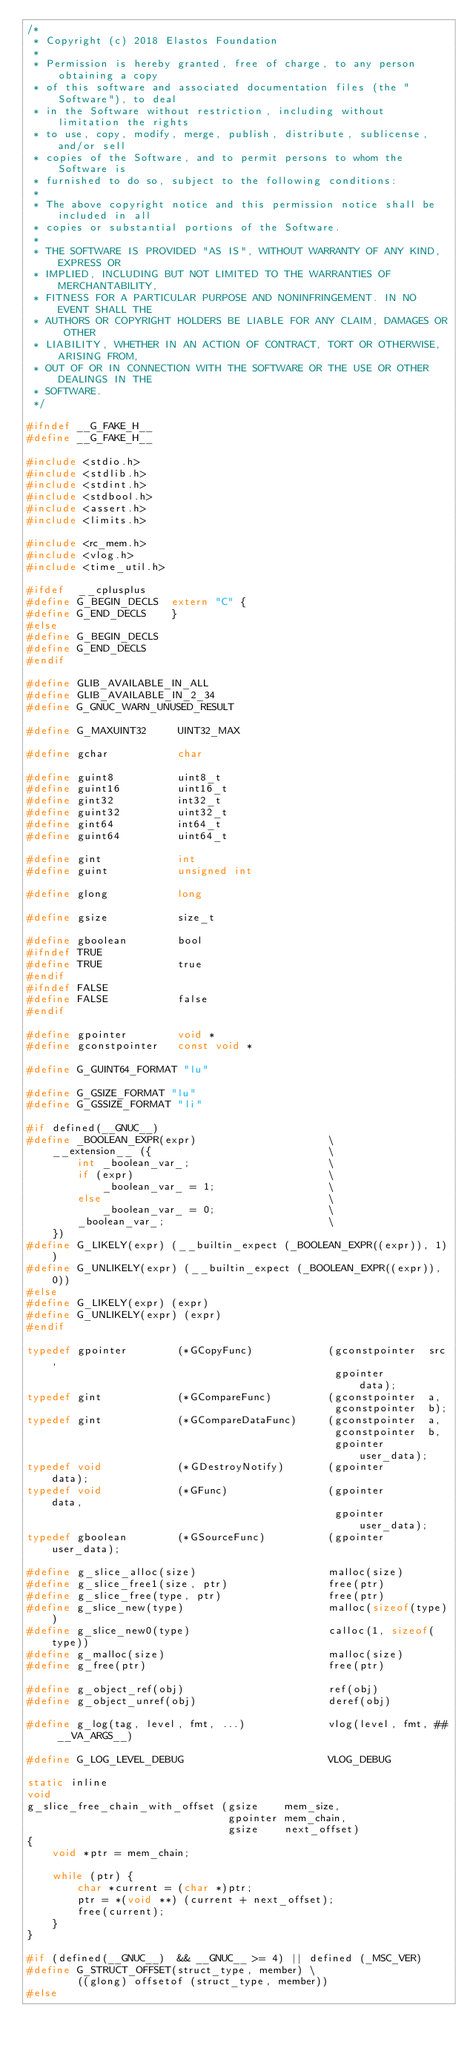<code> <loc_0><loc_0><loc_500><loc_500><_C_>/*
 * Copyright (c) 2018 Elastos Foundation
 *
 * Permission is hereby granted, free of charge, to any person obtaining a copy
 * of this software and associated documentation files (the "Software"), to deal
 * in the Software without restriction, including without limitation the rights
 * to use, copy, modify, merge, publish, distribute, sublicense, and/or sell
 * copies of the Software, and to permit persons to whom the Software is
 * furnished to do so, subject to the following conditions:
 *
 * The above copyright notice and this permission notice shall be included in all
 * copies or substantial portions of the Software.
 *
 * THE SOFTWARE IS PROVIDED "AS IS", WITHOUT WARRANTY OF ANY KIND, EXPRESS OR
 * IMPLIED, INCLUDING BUT NOT LIMITED TO THE WARRANTIES OF MERCHANTABILITY,
 * FITNESS FOR A PARTICULAR PURPOSE AND NONINFRINGEMENT. IN NO EVENT SHALL THE
 * AUTHORS OR COPYRIGHT HOLDERS BE LIABLE FOR ANY CLAIM, DAMAGES OR OTHER
 * LIABILITY, WHETHER IN AN ACTION OF CONTRACT, TORT OR OTHERWISE, ARISING FROM,
 * OUT OF OR IN CONNECTION WITH THE SOFTWARE OR THE USE OR OTHER DEALINGS IN THE
 * SOFTWARE.
 */

#ifndef __G_FAKE_H__
#define __G_FAKE_H__

#include <stdio.h>
#include <stdlib.h>
#include <stdint.h>
#include <stdbool.h>
#include <assert.h>
#include <limits.h>

#include <rc_mem.h>
#include <vlog.h>
#include <time_util.h>

#ifdef  __cplusplus
#define G_BEGIN_DECLS  extern "C" {
#define G_END_DECLS    }
#else
#define G_BEGIN_DECLS
#define G_END_DECLS
#endif

#define GLIB_AVAILABLE_IN_ALL
#define GLIB_AVAILABLE_IN_2_34
#define G_GNUC_WARN_UNUSED_RESULT

#define G_MAXUINT32     UINT32_MAX

#define gchar           char

#define guint8          uint8_t
#define guint16         uint16_t
#define gint32          int32_t
#define guint32         uint32_t
#define gint64          int64_t
#define guint64         uint64_t

#define gint            int
#define guint           unsigned int

#define glong           long

#define gsize           size_t

#define gboolean        bool
#ifndef TRUE
#define TRUE            true
#endif
#ifndef FALSE
#define FALSE           false
#endif

#define gpointer        void *
#define gconstpointer   const void *

#define G_GUINT64_FORMAT "lu"

#define G_GSIZE_FORMAT "lu"
#define G_GSSIZE_FORMAT "li"

#if defined(__GNUC__)
#define _BOOLEAN_EXPR(expr)                     \
    __extension__ ({                            \
        int _boolean_var_;                      \
        if (expr)                               \
            _boolean_var_ = 1;                  \
        else                                    \
            _boolean_var_ = 0;                  \
        _boolean_var_;                          \
    })
#define G_LIKELY(expr) (__builtin_expect (_BOOLEAN_EXPR((expr)), 1))
#define G_UNLIKELY(expr) (__builtin_expect (_BOOLEAN_EXPR((expr)), 0))
#else
#define G_LIKELY(expr) (expr)
#define G_UNLIKELY(expr) (expr)
#endif

typedef gpointer        (*GCopyFunc)            (gconstpointer  src,
                                                 gpointer       data);
typedef gint            (*GCompareFunc)         (gconstpointer  a,
                                                 gconstpointer  b);
typedef gint            (*GCompareDataFunc)     (gconstpointer  a,
                                                 gconstpointer  b,
                                                 gpointer       user_data);
typedef void            (*GDestroyNotify)       (gpointer       data);
typedef void            (*GFunc)                (gpointer       data,
                                                 gpointer       user_data);
typedef gboolean        (*GSourceFunc)          (gpointer       user_data);

#define g_slice_alloc(size)                     malloc(size)
#define g_slice_free1(size, ptr)                free(ptr)
#define g_slice_free(type, ptr)                 free(ptr)
#define g_slice_new(type)                       malloc(sizeof(type))
#define g_slice_new0(type)                      calloc(1, sizeof(type))
#define g_malloc(size)                          malloc(size)
#define g_free(ptr)                             free(ptr)

#define g_object_ref(obj)                       ref(obj)
#define g_object_unref(obj)                     deref(obj)

#define g_log(tag, level, fmt, ...)             vlog(level, fmt, ## __VA_ARGS__)

#define G_LOG_LEVEL_DEBUG                       VLOG_DEBUG

static inline
void
g_slice_free_chain_with_offset (gsize    mem_size,
                                gpointer mem_chain,
                                gsize    next_offset)
{
    void *ptr = mem_chain;

    while (ptr) {
        char *current = (char *)ptr;
        ptr = *(void **) (current + next_offset);
        free(current);
    }
}

#if (defined(__GNUC__)  && __GNUC__ >= 4) || defined (_MSC_VER)
#define G_STRUCT_OFFSET(struct_type, member) \
        ((glong) offsetof (struct_type, member))
#else</code> 